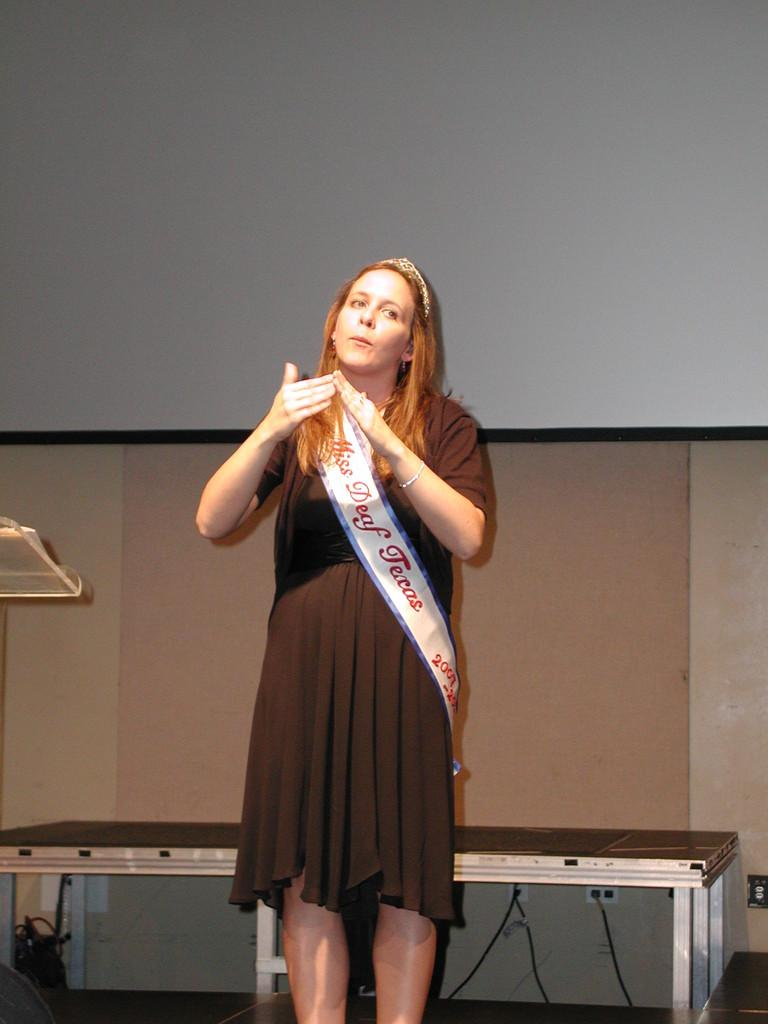Who is present in the image? There is a woman in the image. What is the woman doing in the image? The woman is standing. What is the woman wearing in the image? The woman is wearing a brown dress with a white cloth on it. What can be seen in the background of the image? There is a white screen, a table, and a wall visible in the image. What type of tank is visible in the image? There is no tank present in the image. What advice or guidance is the woman providing as a coach in the image? The image does not depict the woman providing any coaching or guidance; she is simply standing. 